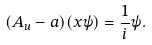<formula> <loc_0><loc_0><loc_500><loc_500>( A _ { u } - a ) ( x \psi ) = \frac { 1 } { i } \psi .</formula> 